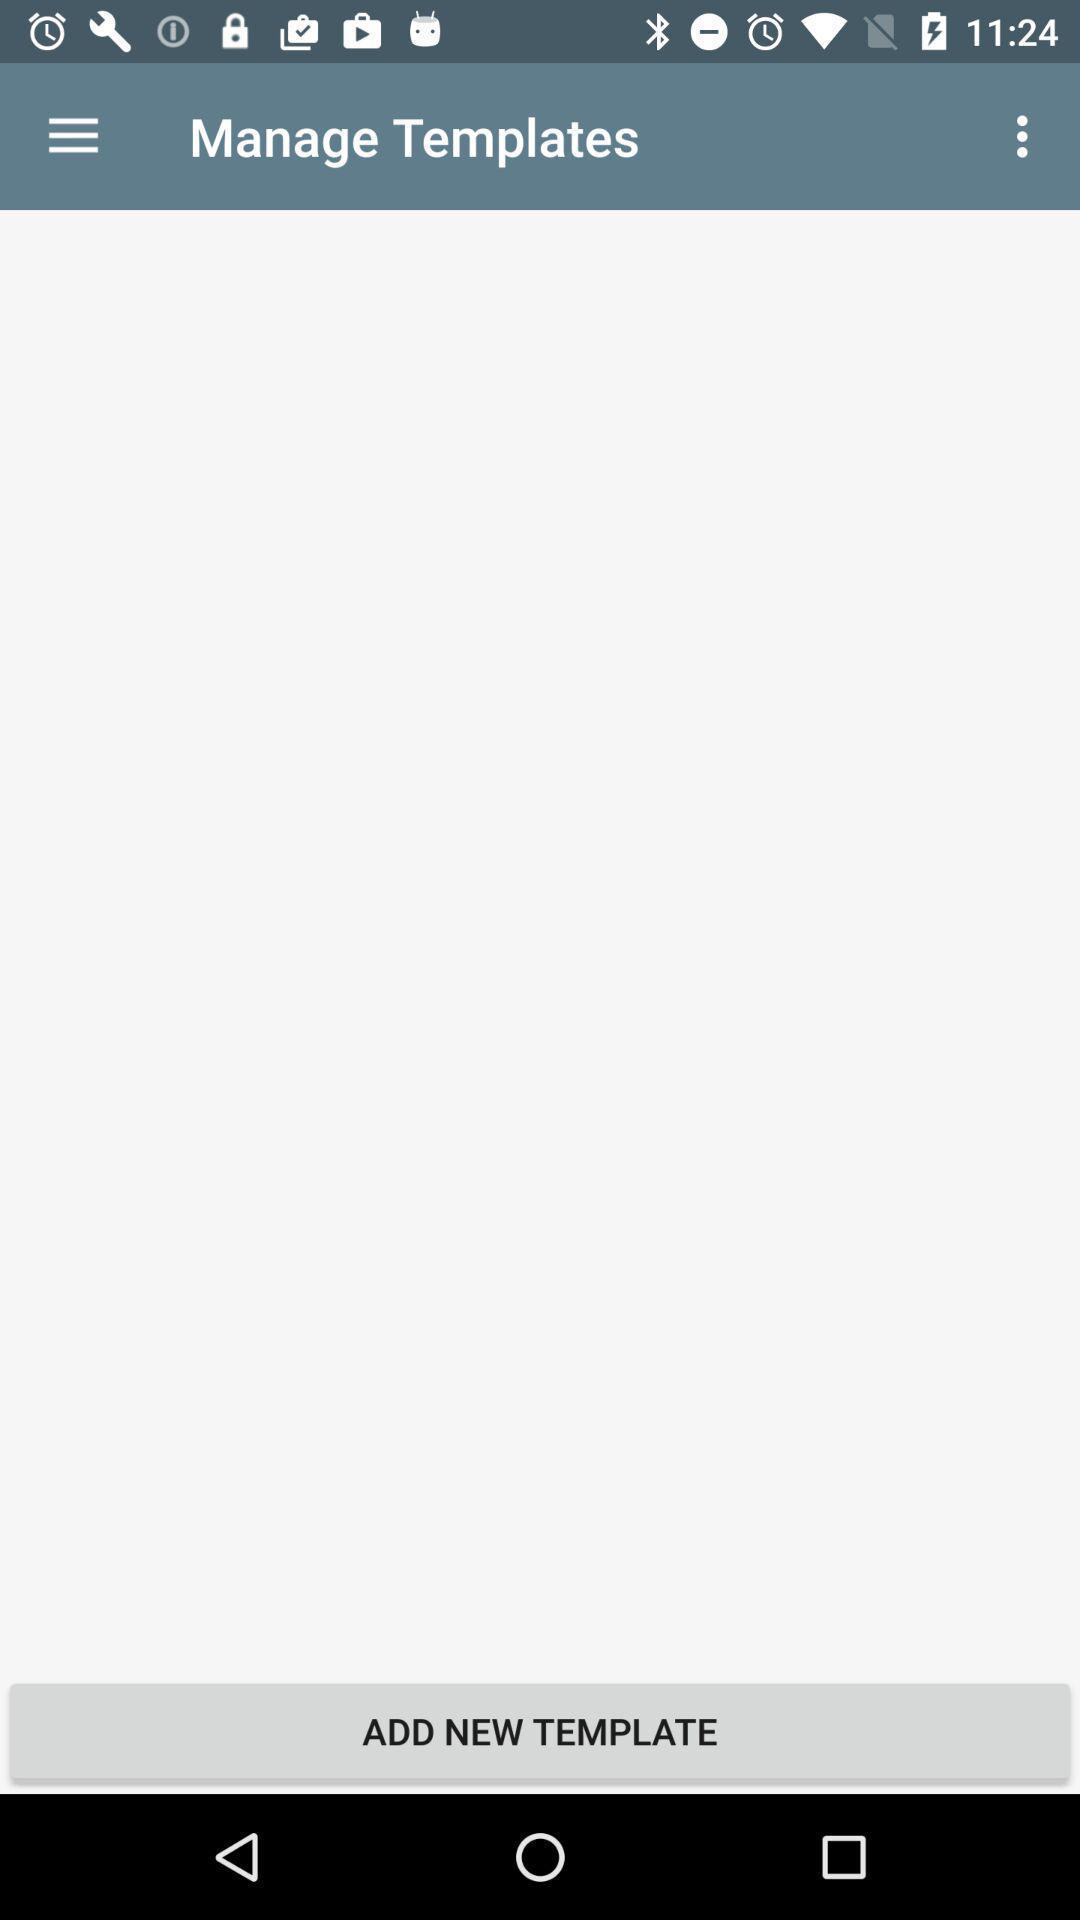Tell me what you see in this picture. Page with add new template option. 